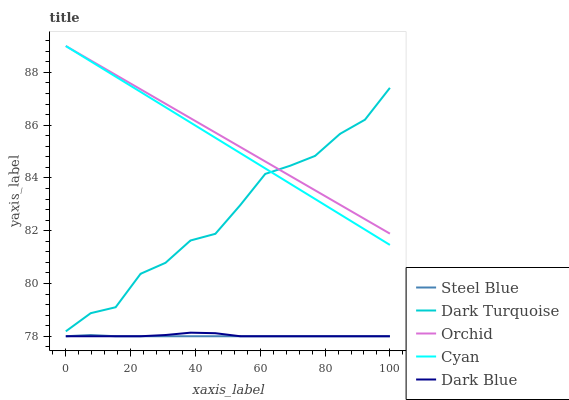Does Cyan have the minimum area under the curve?
Answer yes or no. No. Does Cyan have the maximum area under the curve?
Answer yes or no. No. Is Cyan the smoothest?
Answer yes or no. No. Is Cyan the roughest?
Answer yes or no. No. Does Cyan have the lowest value?
Answer yes or no. No. Does Steel Blue have the highest value?
Answer yes or no. No. Is Steel Blue less than Cyan?
Answer yes or no. Yes. Is Dark Turquoise greater than Dark Blue?
Answer yes or no. Yes. Does Steel Blue intersect Cyan?
Answer yes or no. No. 